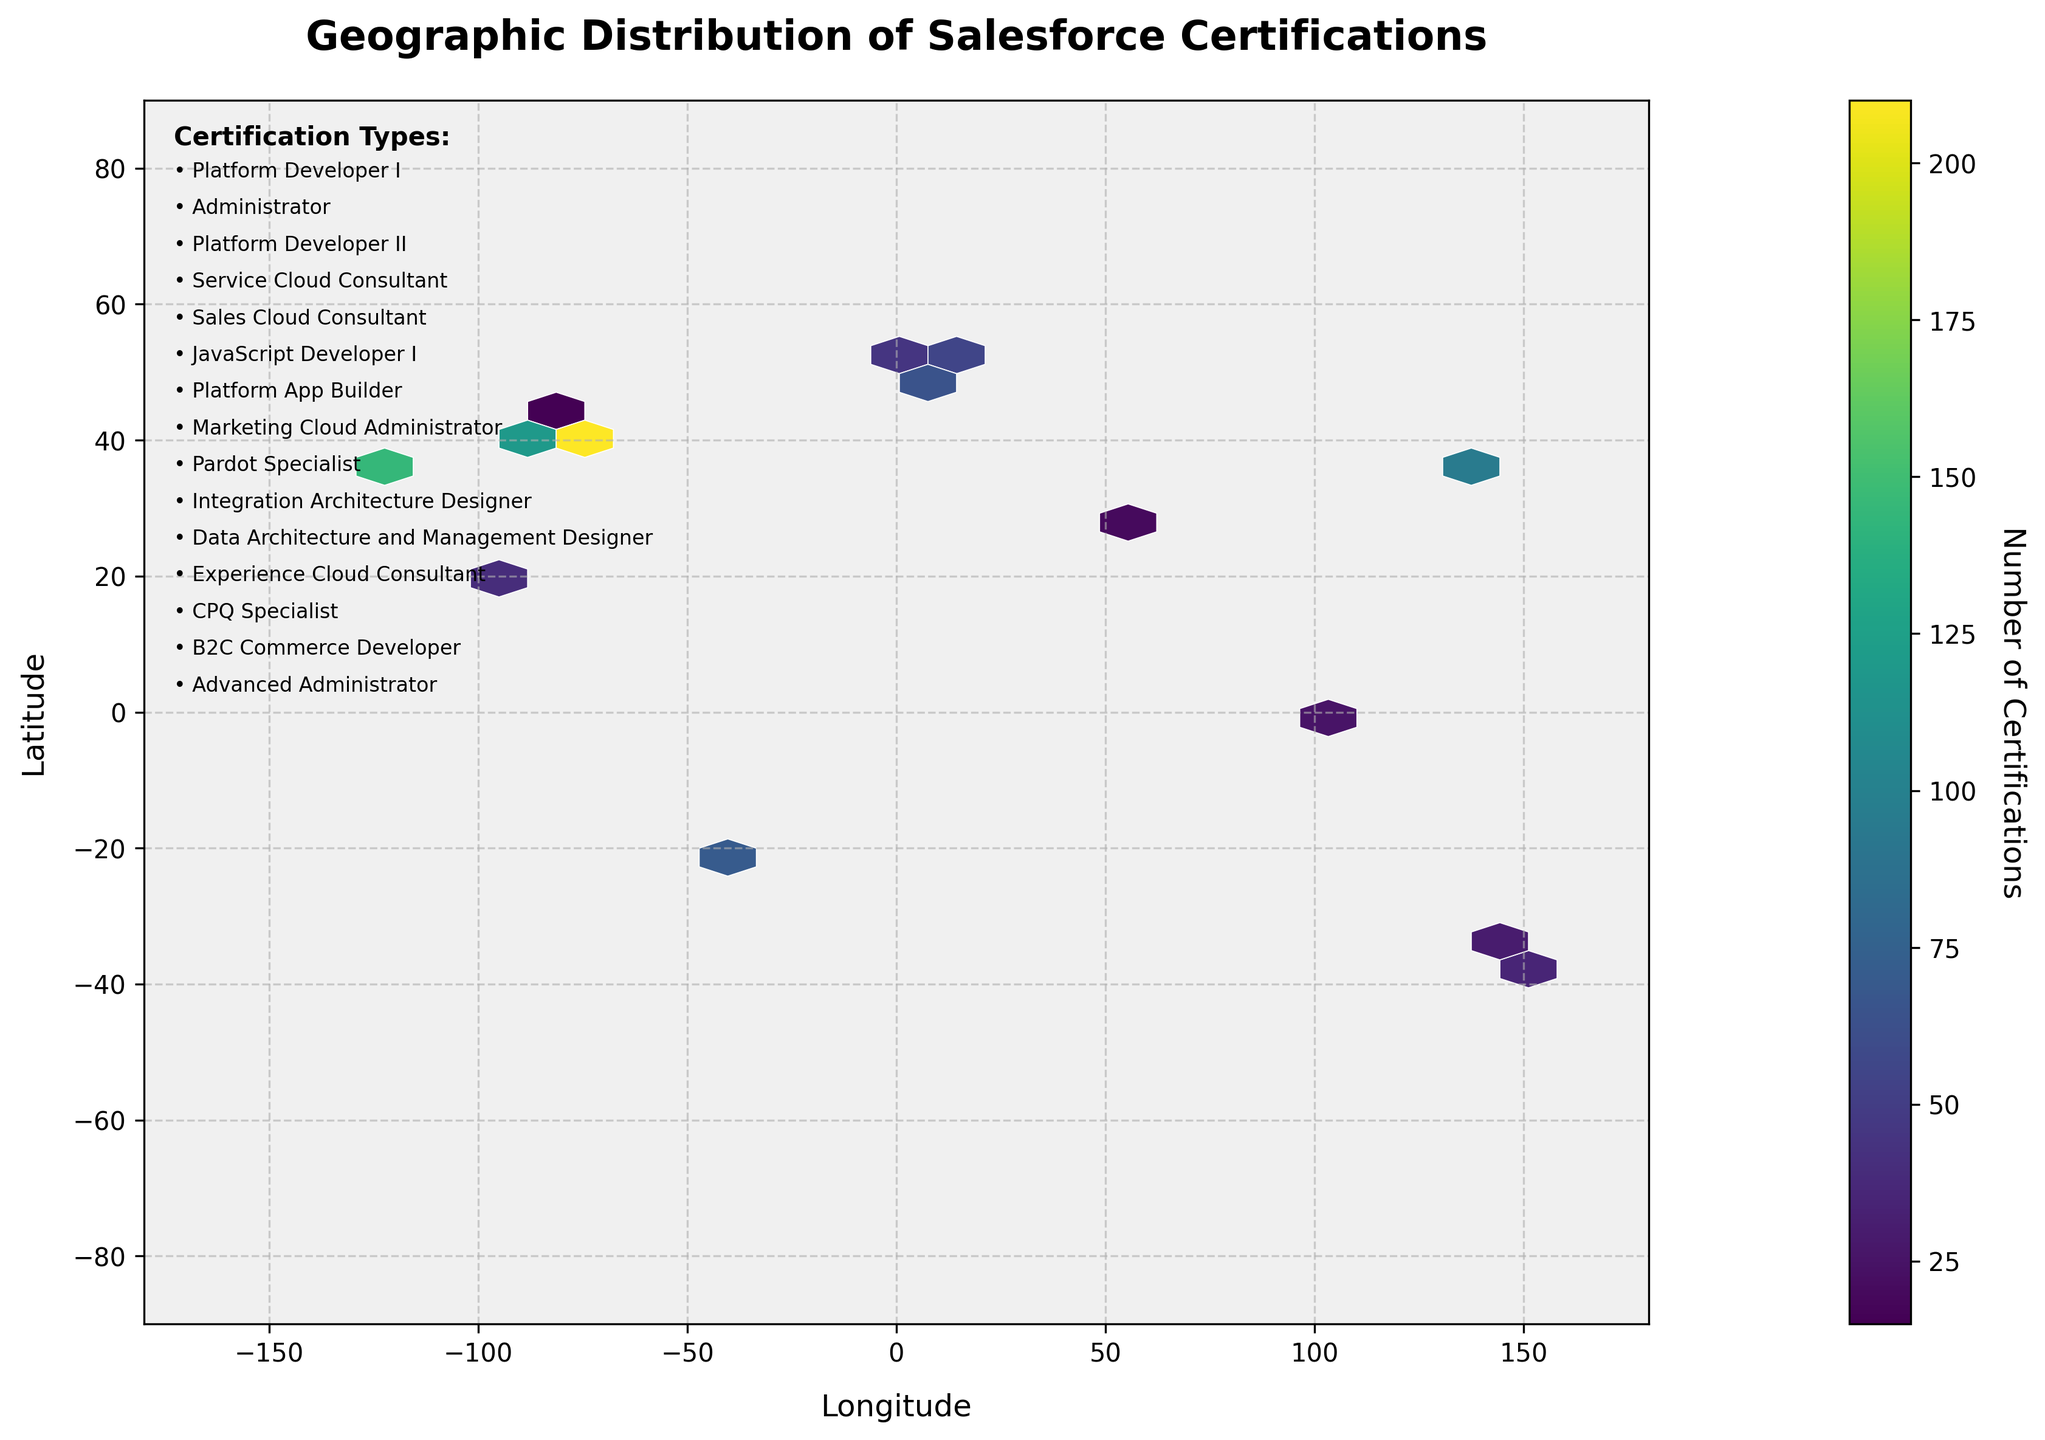What is the title of the figure? The title of the figure is written at the top center of the plot. It reads "Geographic Distribution of Salesforce Certifications."
Answer: Geographic Distribution of Salesforce Certifications How many certification types are listed in the annotation? The annotation on the upper-left corner lists the certification types found in the dataset. By counting the dots and certification names, we can determine there are 14 certification types.
Answer: 14 Which geographic location has the highest count of Salesforce certifications? By examining the hexbin plot, the area with the darkest color indicates the highest concentration. The location around New York City (40.7128, -74.0060) has the darkest hexagonal bin, representing the highest count, which is 210.
Answer: New York City (40.7128, -74.0060) What color represents the highest density of certifications on the plot? According to the color bar on the right-hand side of the plot, the color that represents the highest density of certifications is near the darkest shade in the viridis color map, which is dark purple or almost black.
Answer: Dark purple or almost black How many total certifications are represented in the plot? To find the total number of certifications, sum up all the counts listed in the data. (145 + 210 + 80 + 65 + 95 + 55 + 120 + 40 + 30 + 25 + 20 + 35 + 15 + 10 + 70) = 1015
Answer: 1015 Which two certification types have the closest counts, and what are their counts? By checking the listed counts for each certification, Platform Developer II and Service Cloud Consultant have the closest counts. Platform Developer II has 80, and Service Cloud Consultant has 65. The difference is 15.
Answer: Platform Developer II (80) and Service Cloud Consultant (65) Is there any location in the Southern Hemisphere with certification counts represented? Examining the plot, we notice several locations in the Southern Hemisphere with represented certifications, such as Sydney (-33.8688, 151.2093) and Melbourne (-37.8136, 144.9631).
Answer: Yes, such as Sydney and Melbourne What is the latitude range covered by the plot? By looking at the y-axis, the latitude ranges from -90 to 90 degrees, as depicted by the vertical axis limits.
Answer: -90 to 90 degrees Which continent seems to have the least concentration of Salesforce certifications? Based on the distribution of the hexbins, Africa appears to have the least concentration, as there are very few or no hexagonal bins representing certifications over the continent.
Answer: Africa 